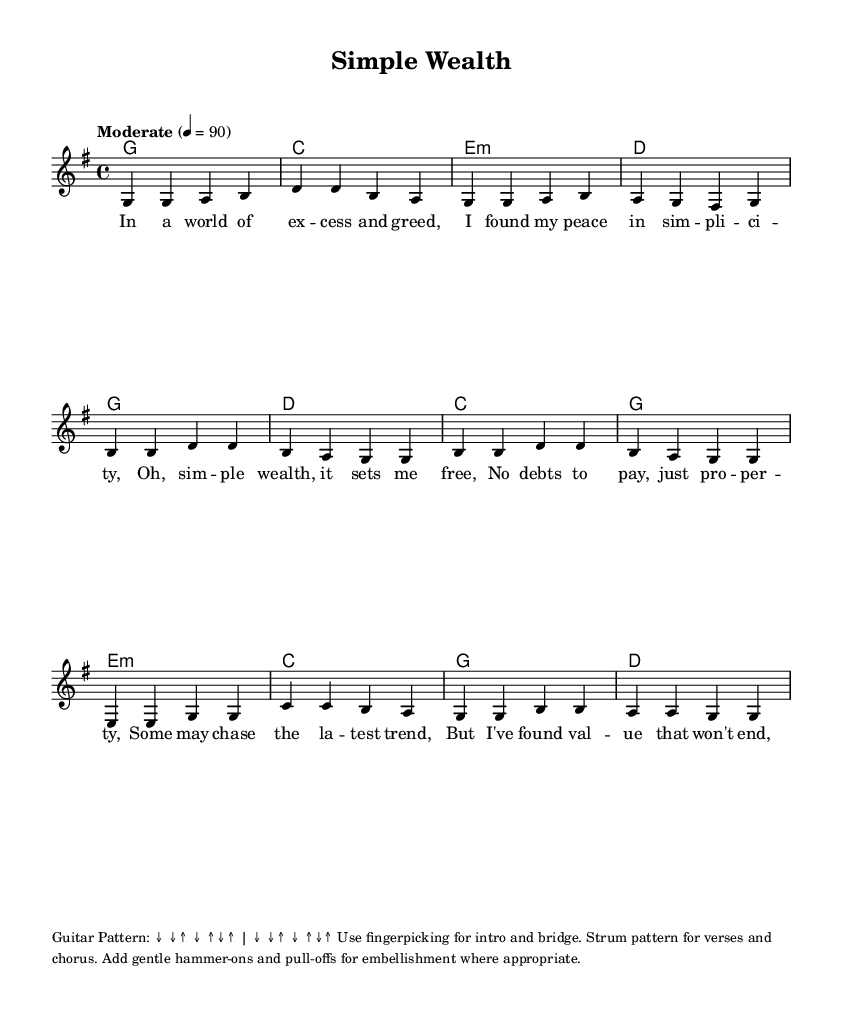What is the key signature of this music? The key signature is G major, which has one sharp (F#).
Answer: G major What is the time signature of this music? The time signature is 4/4, indicating four beats per measure.
Answer: 4/4 What is the tempo marking for this piece? The tempo marking is "Moderate" at 90 beats per minute.
Answer: Moderate 4 = 90 How many sections does the song have? The song has three main sections: Verse, Chorus, and Bridge.
Answer: Three What chord follows the "C" chord in the verse? The chord that follows the "C" chord in the verse is "E minor."
Answer: E minor What technique is suggested for the introduction and bridge? The technique suggested for the introduction and bridge is fingerpicking.
Answer: Fingerpicking What thematic focus does the song celebrate? The song celebrates simple living and financial independence.
Answer: Simple living and financial independence 